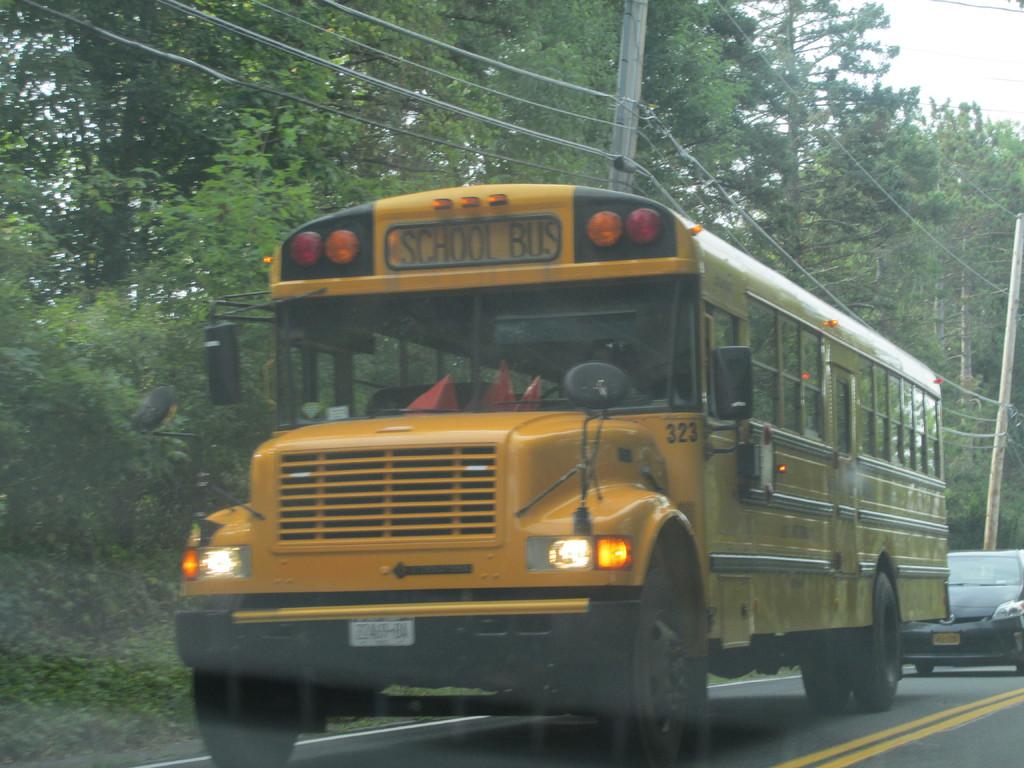What is the school bus number?
Your answer should be very brief. 323. 